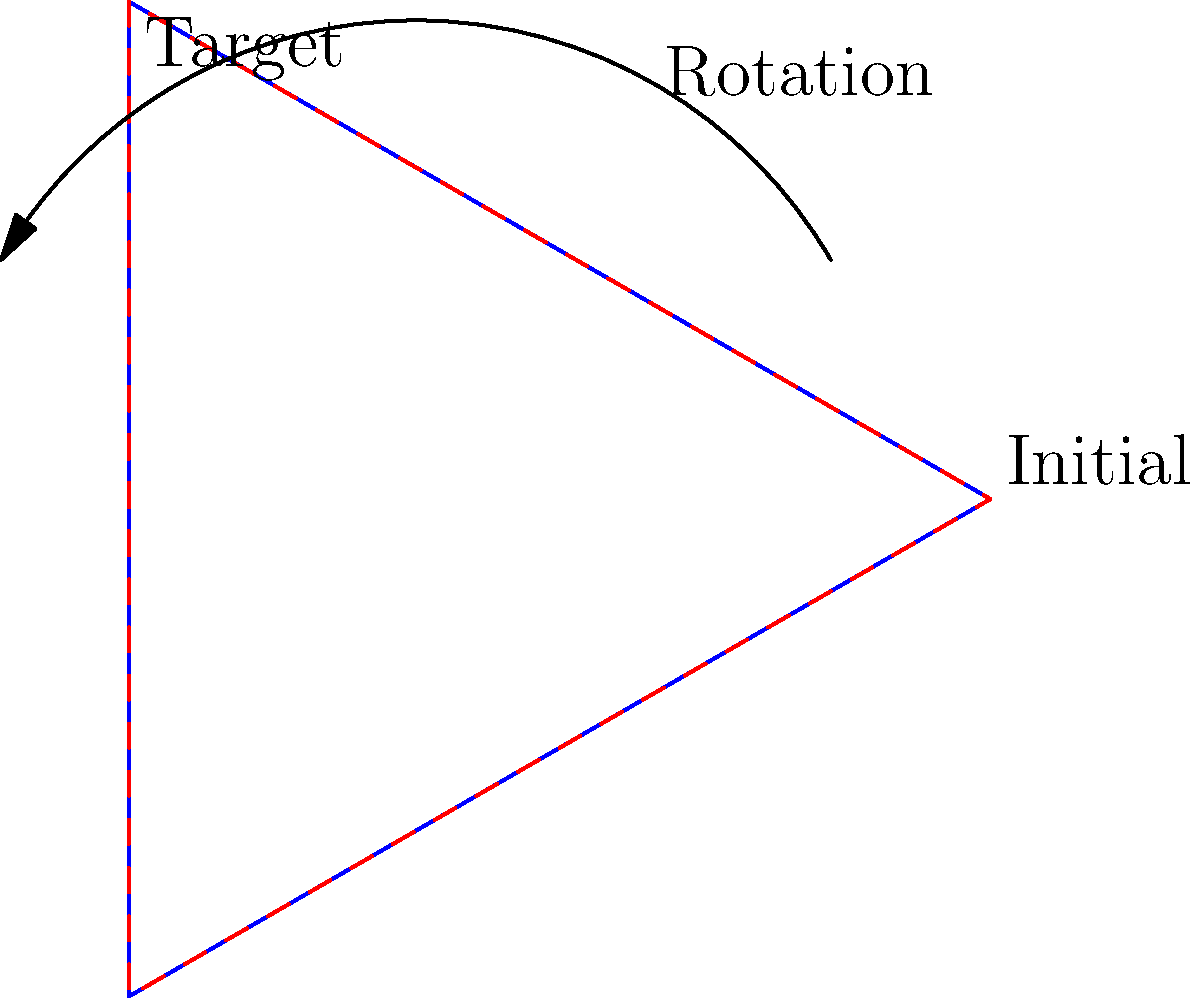In the assembly of a starship's navigational array, a triangular component needs to be rotated to align with its target position. Given that the initial position of the component is rotated 30 degrees clockwise from the vertical axis, and the target position is rotated 30 degrees counterclockwise from the vertical axis, what is the total angle of rotation required to align the component with its target position? To solve this problem, let's break it down step by step:

1. Initial position: The component is rotated 30 degrees clockwise from the vertical axis.
   This can be represented as -30 degrees (negative because it's clockwise).

2. Target position: The target is rotated 30 degrees counterclockwise from the vertical axis.
   This can be represented as +30 degrees (positive because it's counterclockwise).

3. To find the total rotation, we need to:
   a) First, rotate the component back to the vertical axis (0 degrees).
   b) Then, rotate it to the target position.

4. Rotating back to vertical:
   From -30 degrees to 0 degrees = 30 degrees counterclockwise

5. Rotating to target:
   From 0 degrees to +30 degrees = 30 degrees counterclockwise

6. Total rotation:
   $$30° + 30° = 60°$$

Therefore, the total angle of rotation required is 60 degrees counterclockwise.

Note: In Star Trek terminology, this could be expressed as "60 degrees to port" assuming the vertical axis represents the ship's forward direction.
Answer: 60 degrees counterclockwise 